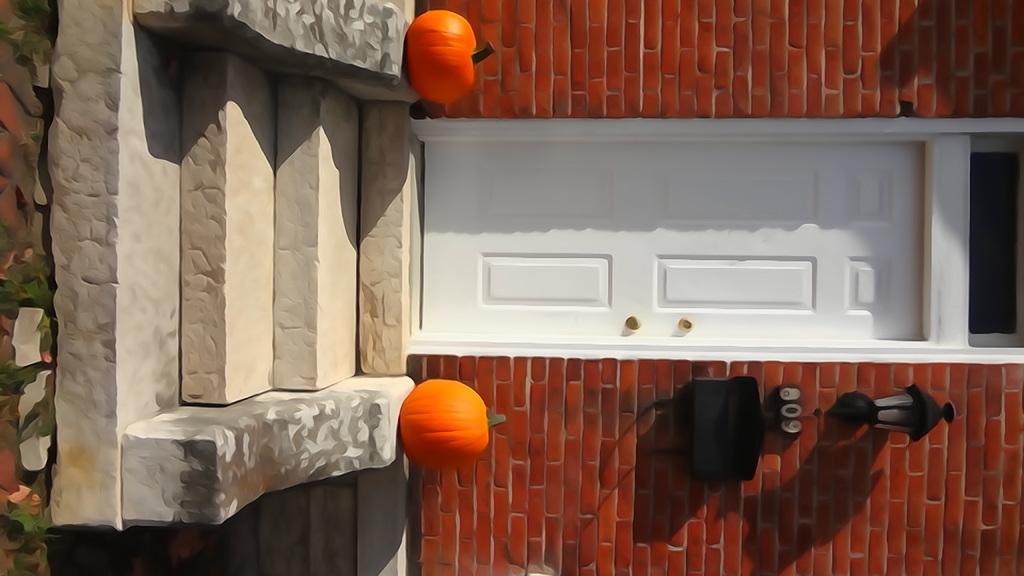Describe this image in one or two sentences. It is a tilted image, in the image there is a door in between the brick wall and in front of the door there are stairs and two pumpkins and there is a lamp fixed to the wall, it looks like a painting. 